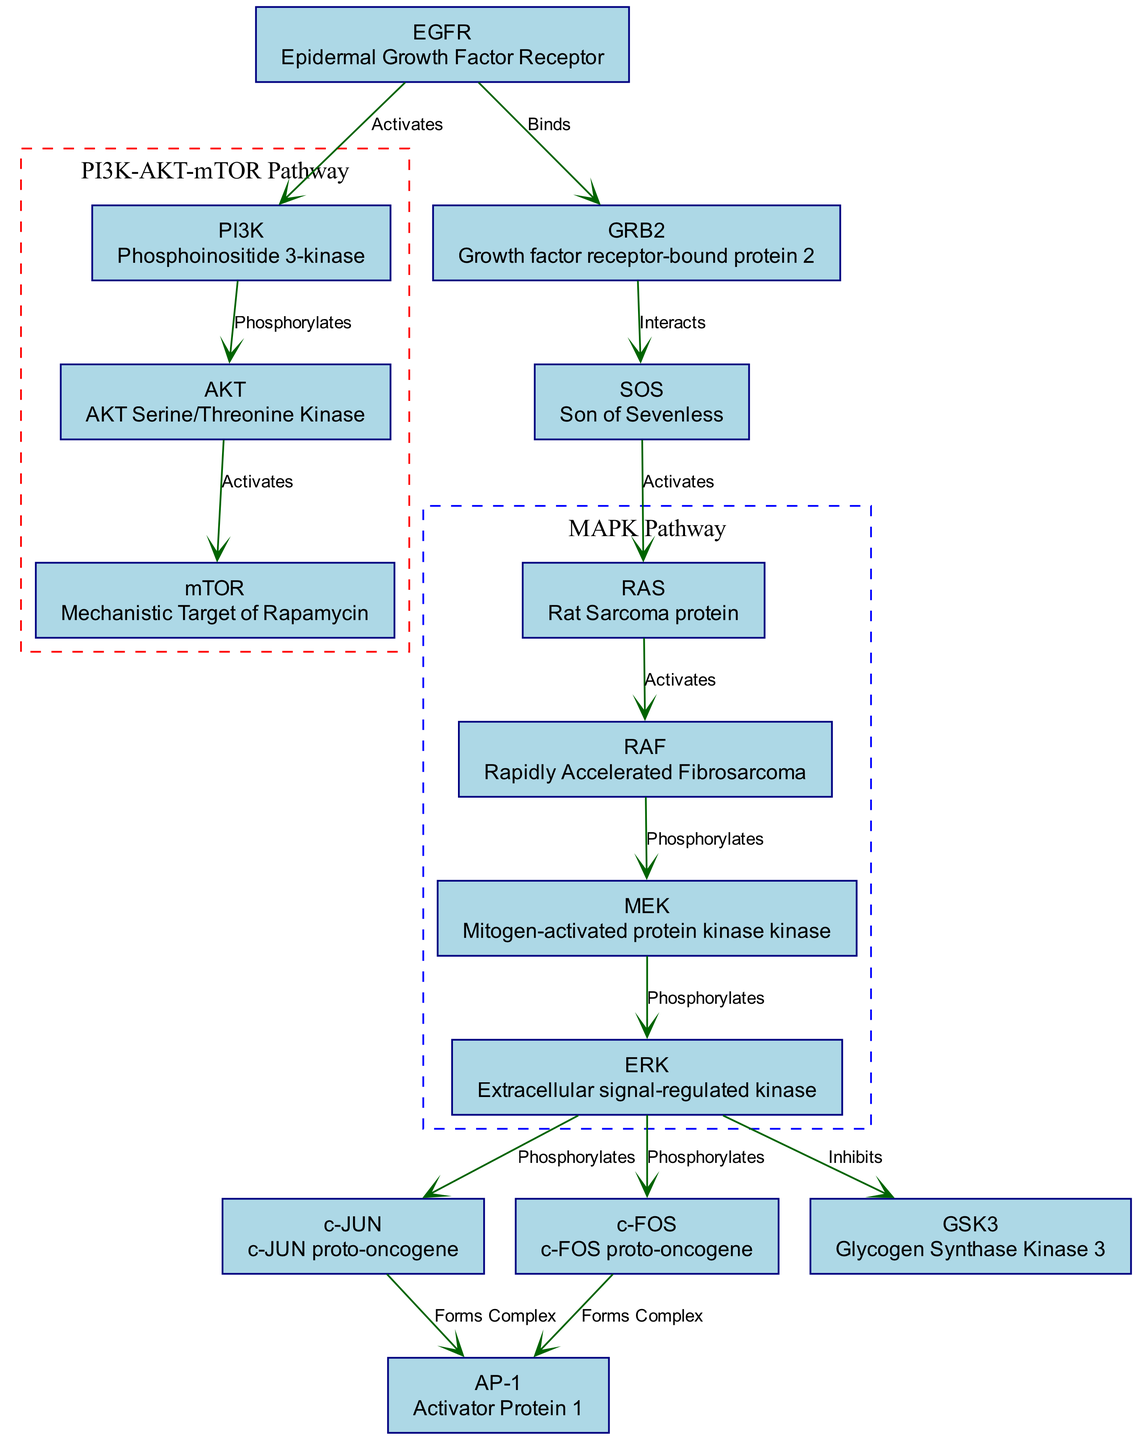What is the total number of nodes in the diagram? The diagram includes a list of nodes that accounts for each distinct component depicted. Counting all the unique nodes in the provided data, there are 14 nodes associated with various proteins and complexes.
Answer: 14 Which protein does EGFR activate? From the edges in the diagram, EGFR is shown to have an activation relationship with PI3K, highlighting its role in signal transduction pathways.
Answer: PI3K What complex is formed by JUN and FOS? According to the diagram, the edges illustrate that JUN and FOS both participate in forming the AP-1 complex, indicating their collaborative role in signaling pathways.
Answer: AP-1 Who phosphorylates ERK? The diagram specifies that MEK is the protein responsible for the phosphorylation of ERK, linking two critical components within the MAPK signaling pathway.
Answer: MEK What is the primary function of RAS in the network? Evaluating the diagram’s edges suggests RAS is mainly involved in activating RAF upon interaction. This indicates RAS acts as a signaling molecule that promotes further pathways in the network.
Answer: Activates How many edges are connecting the nodes in the MAPK pathway? Analyzing the edges within the specific cluster named MAPK pathway, I can identify 5 connections among the involved proteins: RAS, RAF, MEK, and ERK. Summing these connections gives a total of 5 edges.
Answer: 5 Which nodes are part of the PI3K-AKT-mTOR pathway? The diagram delineates a specific cluster emphasizing the proteins included in the PI3K-AKT-mTOR pathway, which consists of PI3K, AKT, and mTOR, representing their interconnected roles in this signaling route.
Answer: PI3K, AKT, mTOR What type of interaction occurs between GRB2 and SOS? The diagram explicitly details that GRB2 and SOS share an "Interacts" relationship, demonstrating their connection within the signaling network and indicating a functional relationship for signal transduction.
Answer: Interacts Which protein is inhibited by ERK? Looking at the edges in the diagram, ERK has a direct inhibitory interaction with GSK3, suggesting the regulatory role of ERK in this signaling context.
Answer: GSK3 